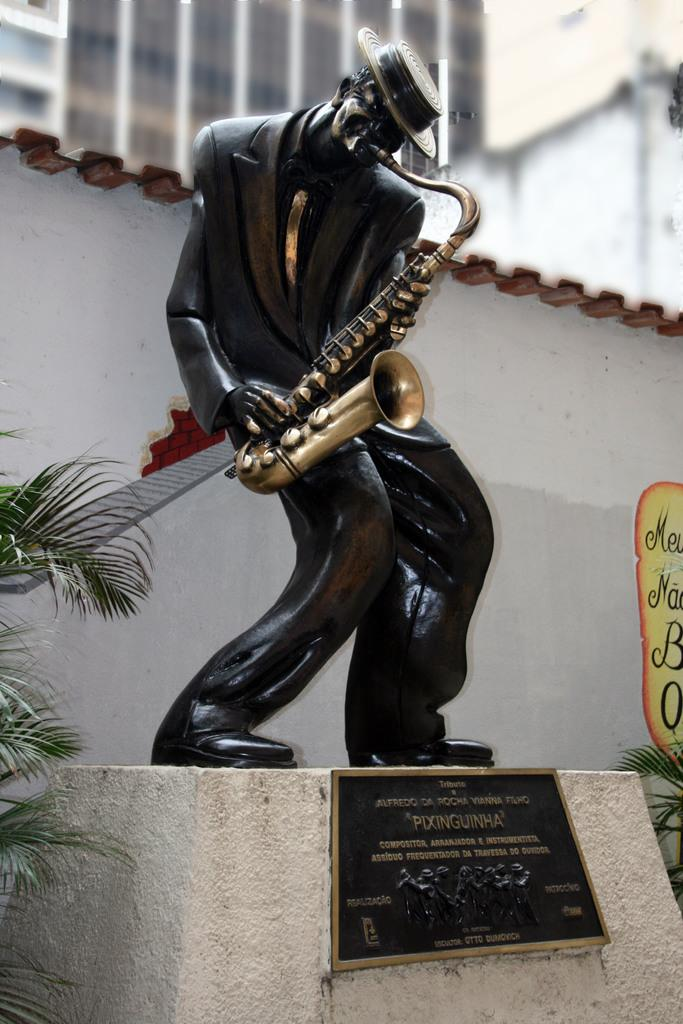What is the main subject of the image? There is a sculpture of a person in the image. What is the person in the sculpture doing? The person in the sculpture is playing a music instrument. What can be seen in the background of the image? There is a building behind the sculpture. Are there any plants visible in the image? Yes, there is a plant in the image. What type of glass is used to create the sculpture? There is no mention of glass being used in the creation of the sculpture, and the material used is not specified in the image. 